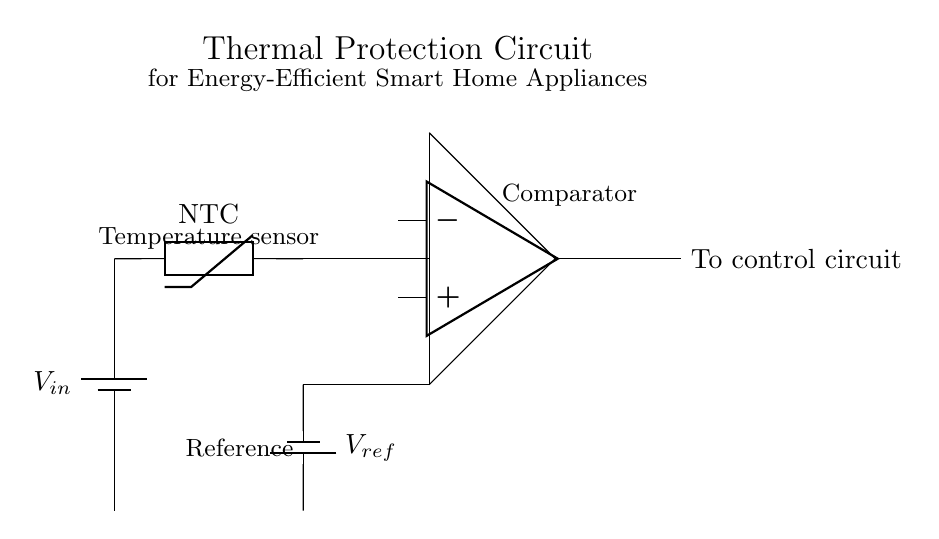What is the type of temperature sensor used in the circuit? The circuit uses an NTC thermistor as a temperature sensor, which is indicated in the diagram. NTC stands for Negative Temperature Coefficient, meaning its resistance decreases as the temperature increases.
Answer: NTC thermistor What component is used to compare the voltage levels? The diagram shows an operational amplifier as the comparator. This is evidenced by the symbol for the op-amp that indicates its function in comparing the voltage from the thermistor with the reference voltage.
Answer: Operational amplifier What is the purpose of the reference voltage in this circuit? The reference voltage serves as a baseline to compare with the voltage signal from the thermistor. It helps determine if the temperature is above or below a predefined threshold for protection purposes.
Answer: Baseline comparison How many power supplies are present in the circuit? There are two power supplies present: one for the input voltage V in and another one for the reference voltage V ref. The circuit shows two separate battery symbols indicating two distinct power sources.
Answer: Two What does the output from the comparator connect to? The output from the comparator connects to the control circuit, which is indicated in the diagram. This suggests that the comparator outputs a signal that will control the operation of the appliance based on the temperature readings.
Answer: Control circuit Why is a thermal protection circuit important for smart home appliances? A thermal protection circuit is essential to prevent overheating of appliances, which can lead to faults or fires. By monitoring the temperature and disabling the appliance when necessary, it enhances safety and energy efficiency.
Answer: Prevents overheating 